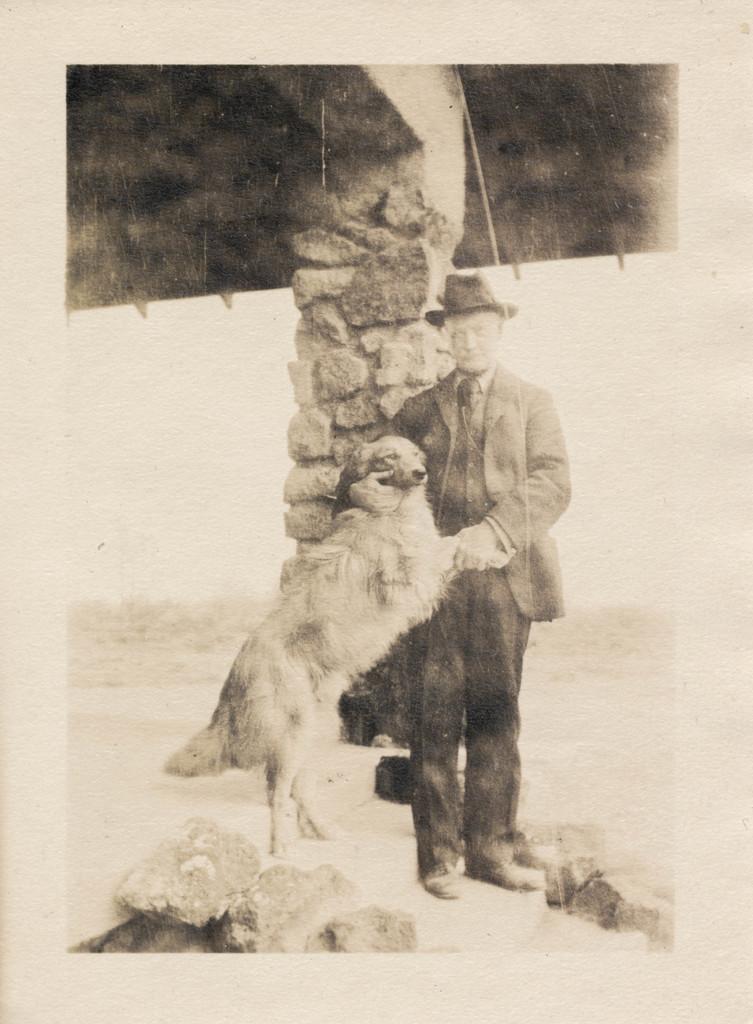Describe this image in one or two sentences. In this image I can see an old photograph in which I can see a person standing and holding a dog and few rocks on the ground. In the background I can see a wall and few trees. 